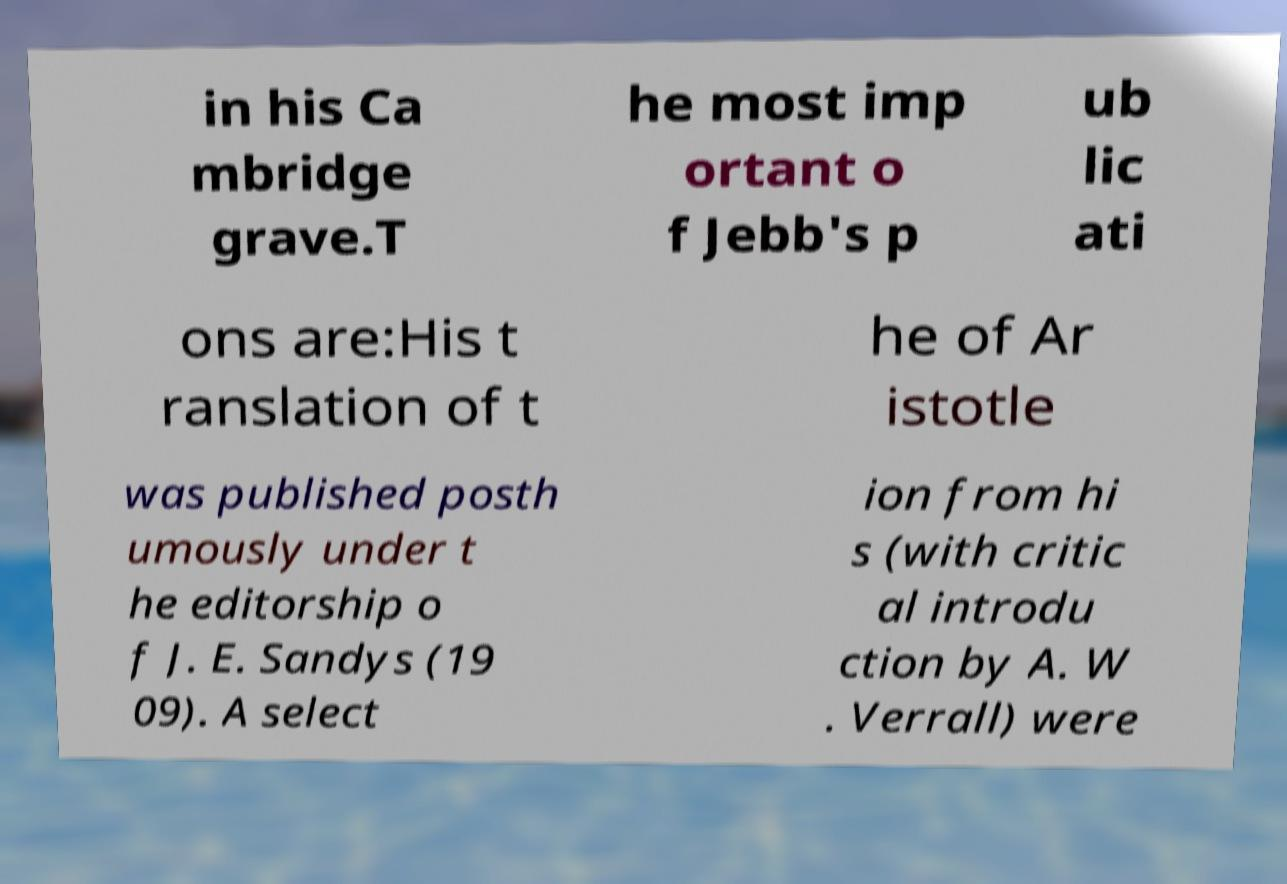Could you assist in decoding the text presented in this image and type it out clearly? in his Ca mbridge grave.T he most imp ortant o f Jebb's p ub lic ati ons are:His t ranslation of t he of Ar istotle was published posth umously under t he editorship o f J. E. Sandys (19 09). A select ion from hi s (with critic al introdu ction by A. W . Verrall) were 